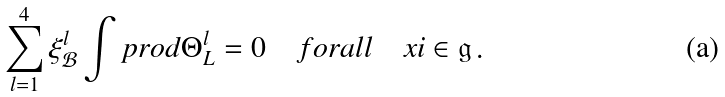Convert formula to latex. <formula><loc_0><loc_0><loc_500><loc_500>\sum _ { l = 1 } ^ { 4 } \xi _ { \mathcal { B } } ^ { l } \int p r o d \Theta _ { L } ^ { l } = 0 \quad f o r a l l \quad x i \in { \mathfrak g } \, .</formula> 